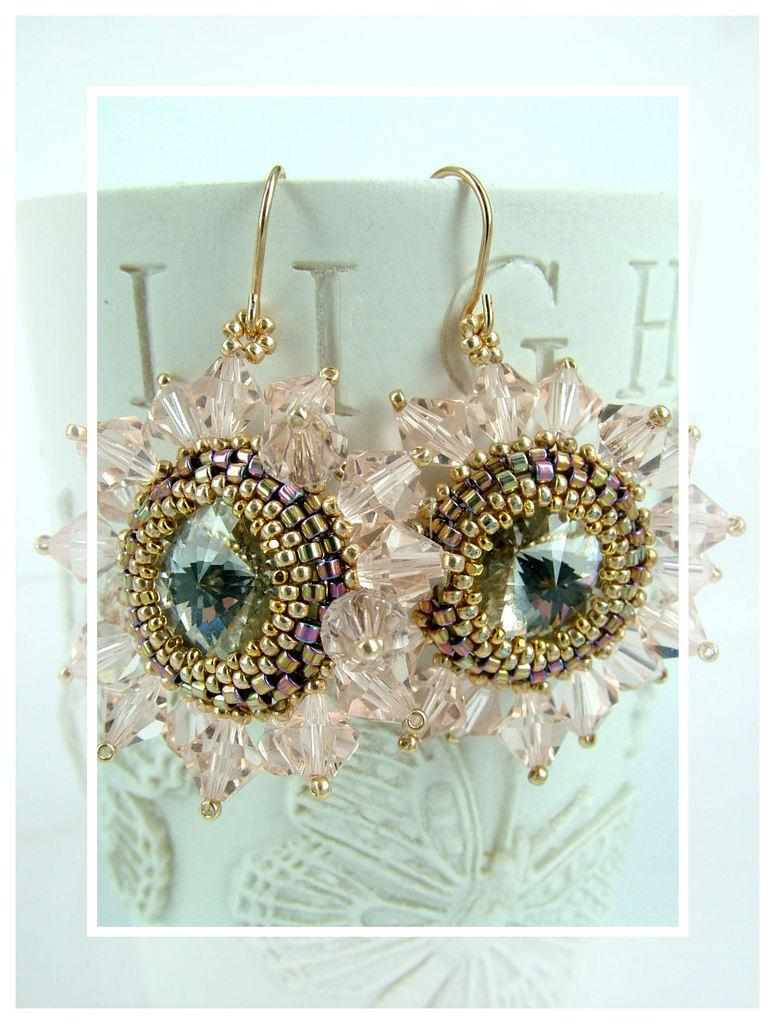What type of jewelry is present in the image? There are two earrings in the image. Where are the earrings placed in the image? The earrings are on a cup. What is the main object in the image? There is a cup in the image. Can you see any blood on the tooth in the image? There is no tooth or blood present in the image. 